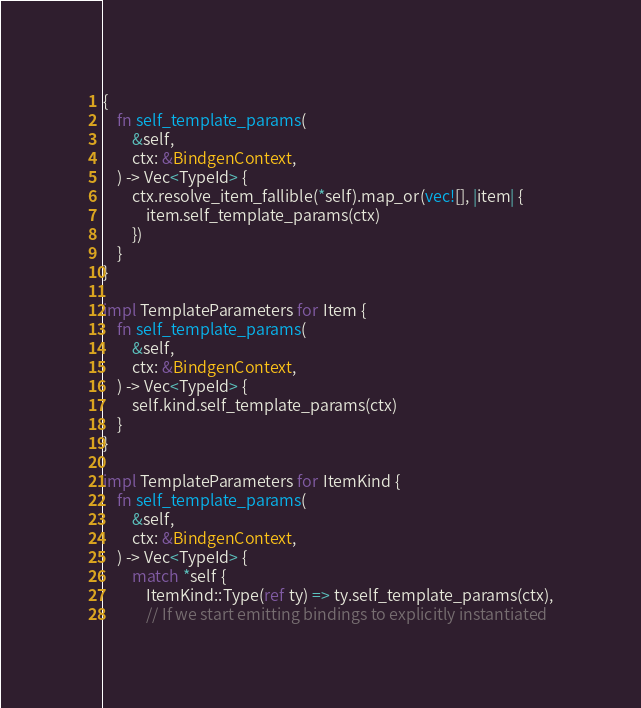<code> <loc_0><loc_0><loc_500><loc_500><_Rust_>{
    fn self_template_params(
        &self,
        ctx: &BindgenContext,
    ) -> Vec<TypeId> {
        ctx.resolve_item_fallible(*self).map_or(vec![], |item| {
            item.self_template_params(ctx)
        })
    }
}

impl TemplateParameters for Item {
    fn self_template_params(
        &self,
        ctx: &BindgenContext,
    ) -> Vec<TypeId> {
        self.kind.self_template_params(ctx)
    }
}

impl TemplateParameters for ItemKind {
    fn self_template_params(
        &self,
        ctx: &BindgenContext,
    ) -> Vec<TypeId> {
        match *self {
            ItemKind::Type(ref ty) => ty.self_template_params(ctx),
            // If we start emitting bindings to explicitly instantiated</code> 